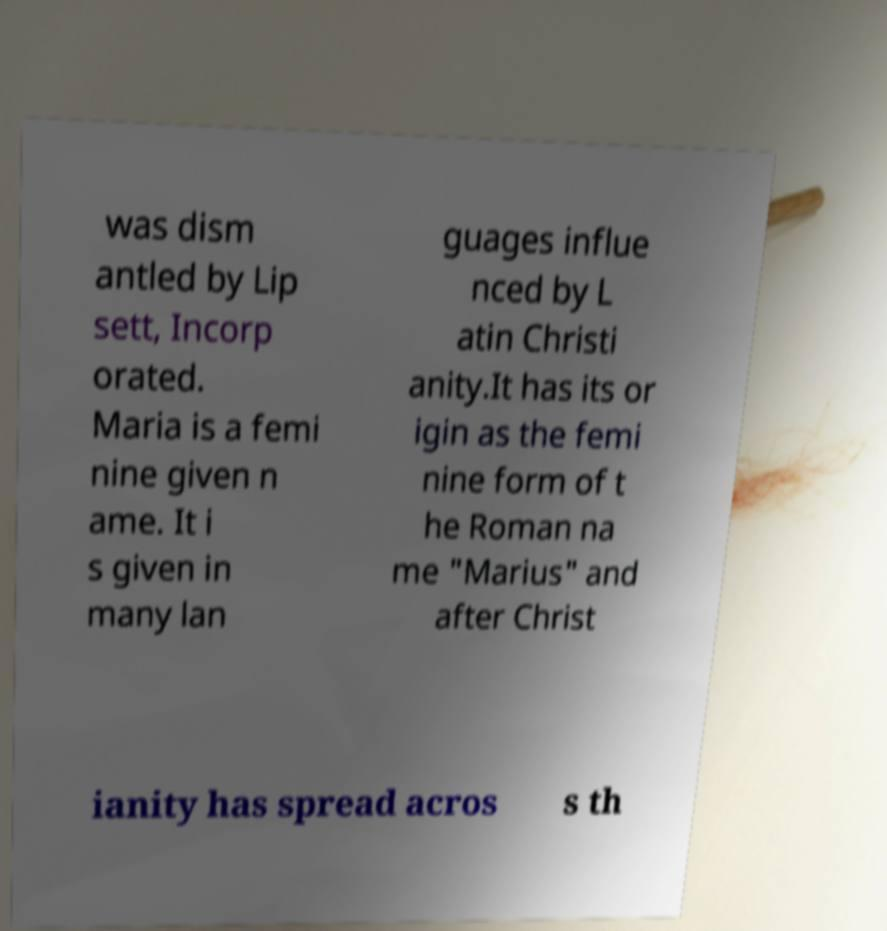I need the written content from this picture converted into text. Can you do that? was dism antled by Lip sett, Incorp orated. Maria is a femi nine given n ame. It i s given in many lan guages influe nced by L atin Christi anity.It has its or igin as the femi nine form of t he Roman na me "Marius" and after Christ ianity has spread acros s th 